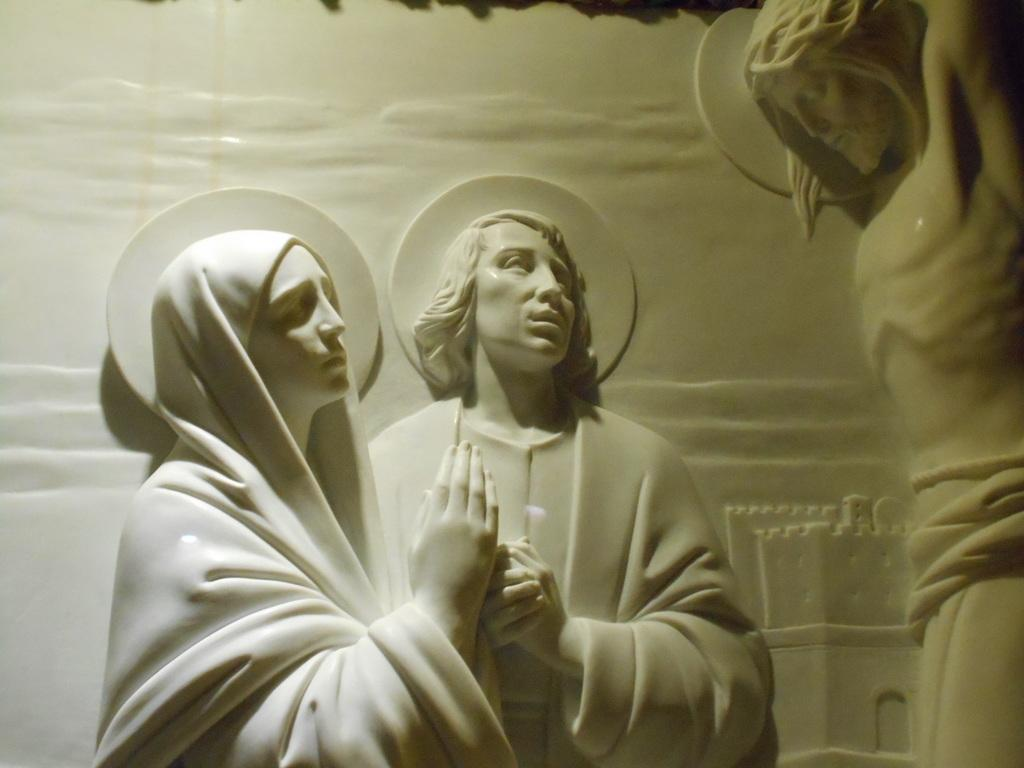What is on the wall in the image? There is a sculpture on the wall in the image. What does the sculpture depict? The sculpture depicts a man and a woman, as well as Jesus. What is the color of the sculpture? The sculpture is white in color. What type of rose is growing in the background of the image? There is no rose present in the image; it features a sculpture on the wall. What type of punishment is being depicted in the sculpture? The sculpture does not depict any form of punishment; it features a man, a woman, and Jesus. 